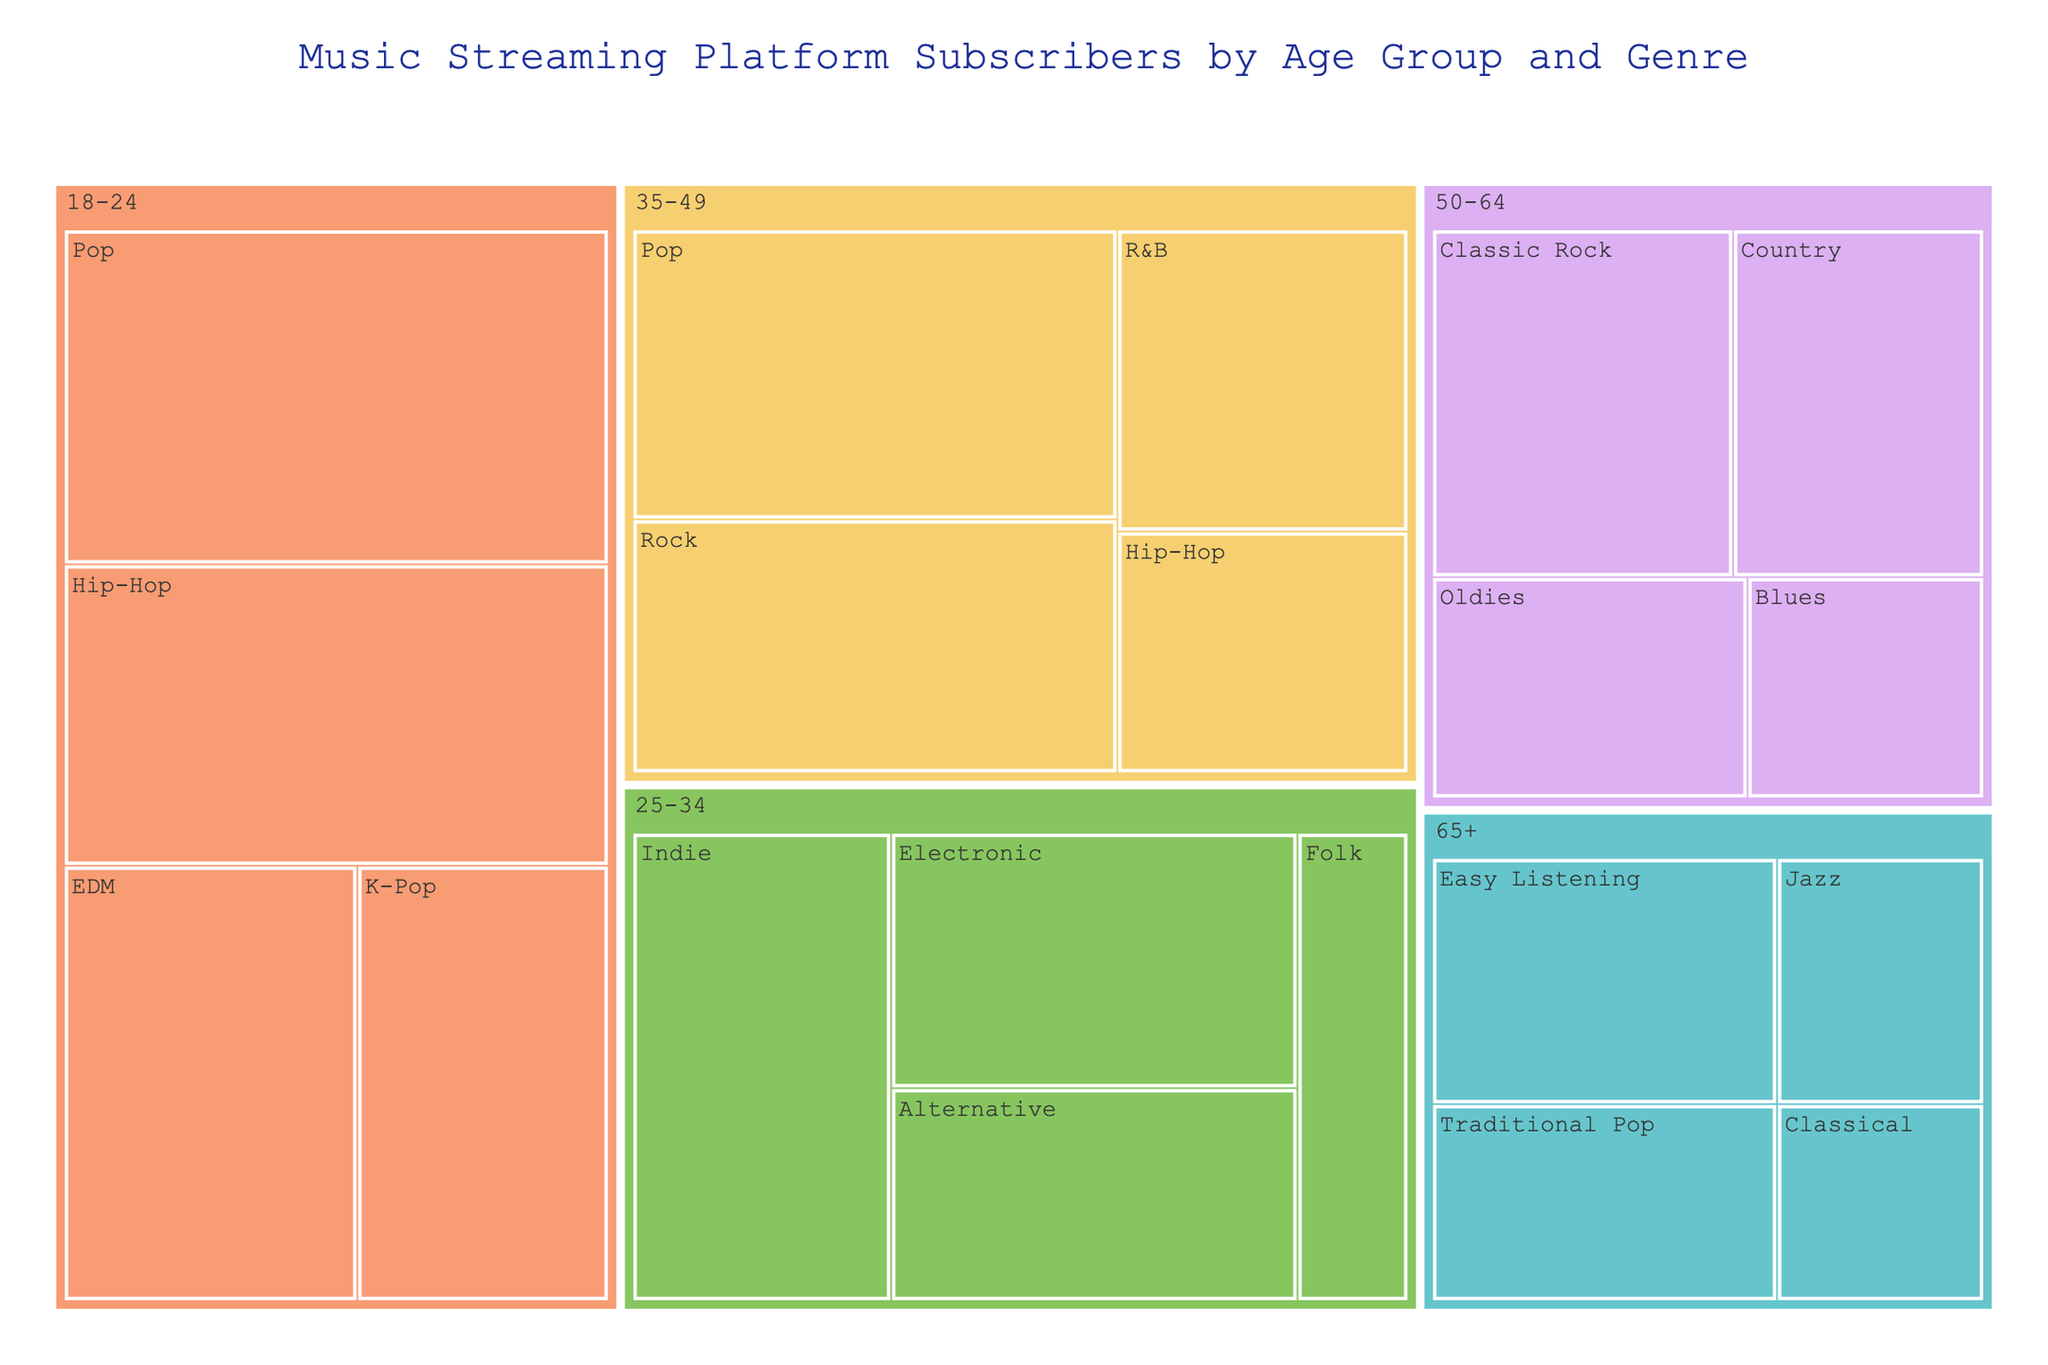What's the most popular genre among subscribers aged 18-24? By looking at the section corresponding to the 18-24 age group, we can see which genre has the largest section. The largest section here is Pop.
Answer: Pop How many subscribers aged 65+ prefer Easy Listening? Locate the Easy Listening section within the 65+ age group and note the number of subscribers labeled inside it, which is 2,500,000.
Answer: 2,500,000 What's the least popular genre for subscribers aged 50-64? Within the 50-64 age group, compare the different genres and their subscriber counts. The genre with the fewest subscribers is Blues with 1,500,000.
Answer: Blues When combining the Pop genre from all age groups, what is the total number of subscribers? Add the subscriber counts for the Pop genre across all age groups: 4,000,000 (35-49) + 5,000,000 (18-24) = 9,000,000.
Answer: 9,000,000 Who has more subscribers: 35-49 for Rock or 25-34 for Indie? Compare the subscriber counts: 35-49 for Rock has 3,500,000 and 25-34 for Indie has 3,500,000. There is an equal number of subscribers for both categories.
Answer: Equal What age group has the largest number of Classical listeners? Look through the chart to see which age group contains Classical listeners and their corresponding number. Classical is only present in the 65+ age group with 1,200,000 subscribers.
Answer: 65+ How many more subscribers does the 18-24 age group have for Hip-Hop compared to the 35-49 age group? Subtract the number of Hip-Hop subscribers in the 35-49 age group (2,000,000) from the number in the 18-24 age group (4,500,000), which equals 2,500,000.
Answer: 2,500,000 What are the total subscribers for all genres combined in the 50-64 age group? Sum up the subscriber counts for all genres within the 50-64 age group: 3,000,000 (Classic Rock) + 2,500,000 (Country) + 2,000,000 (Oldies) + 1,500,000 (Blues) = 9,000,000.
Answer: 9,000,000 Which genre has the most subscribers in the 25-34 age group? Look at the different genre sections within the 25-34 age group and compare their sizes. The genre with the most subscribers is Indie.
Answer: Indie 